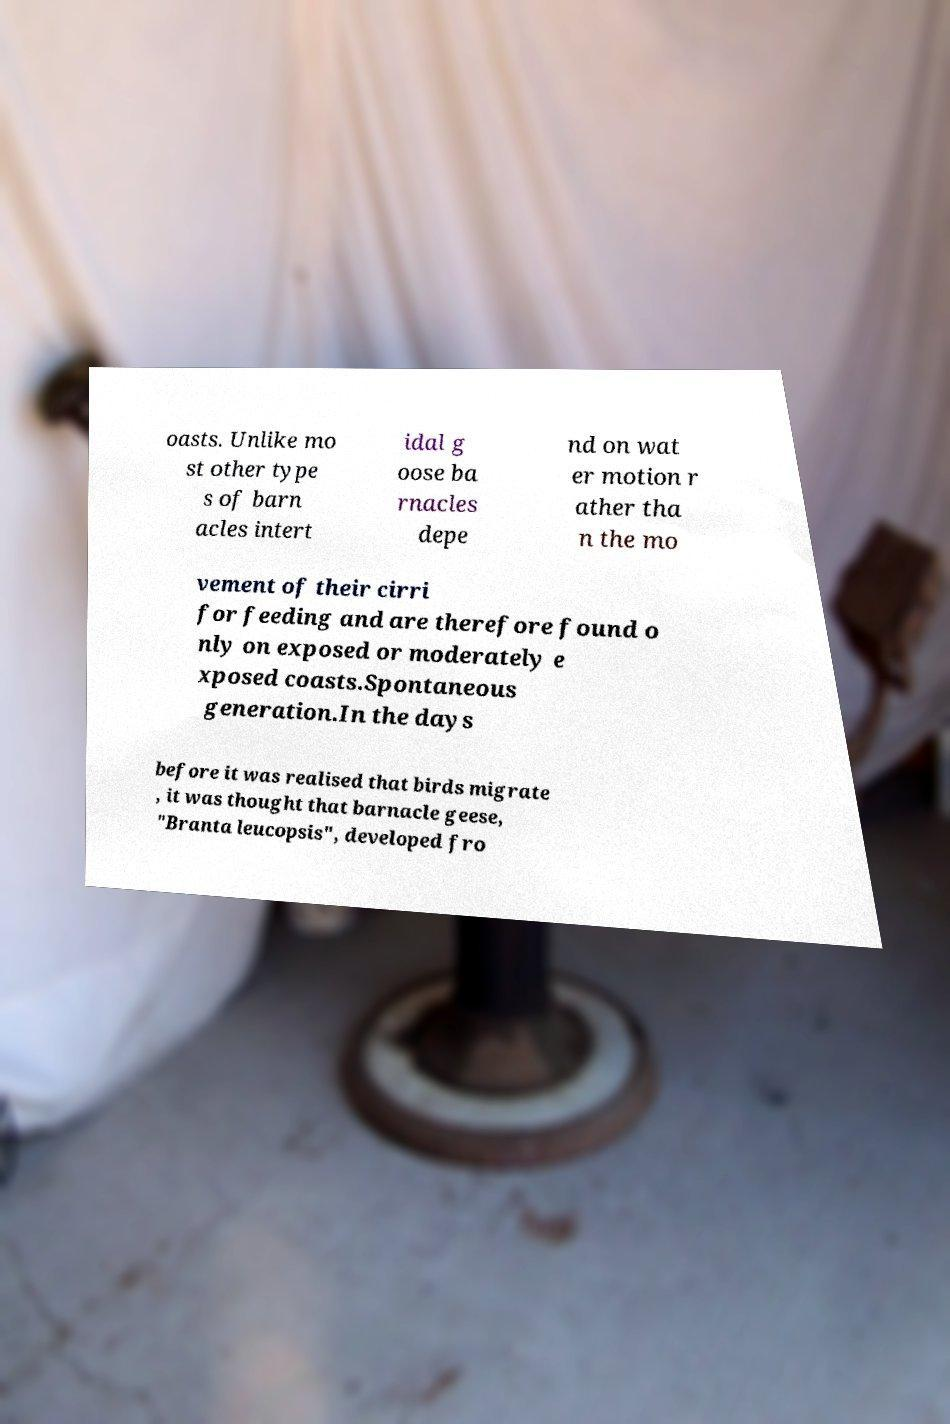Could you extract and type out the text from this image? oasts. Unlike mo st other type s of barn acles intert idal g oose ba rnacles depe nd on wat er motion r ather tha n the mo vement of their cirri for feeding and are therefore found o nly on exposed or moderately e xposed coasts.Spontaneous generation.In the days before it was realised that birds migrate , it was thought that barnacle geese, "Branta leucopsis", developed fro 